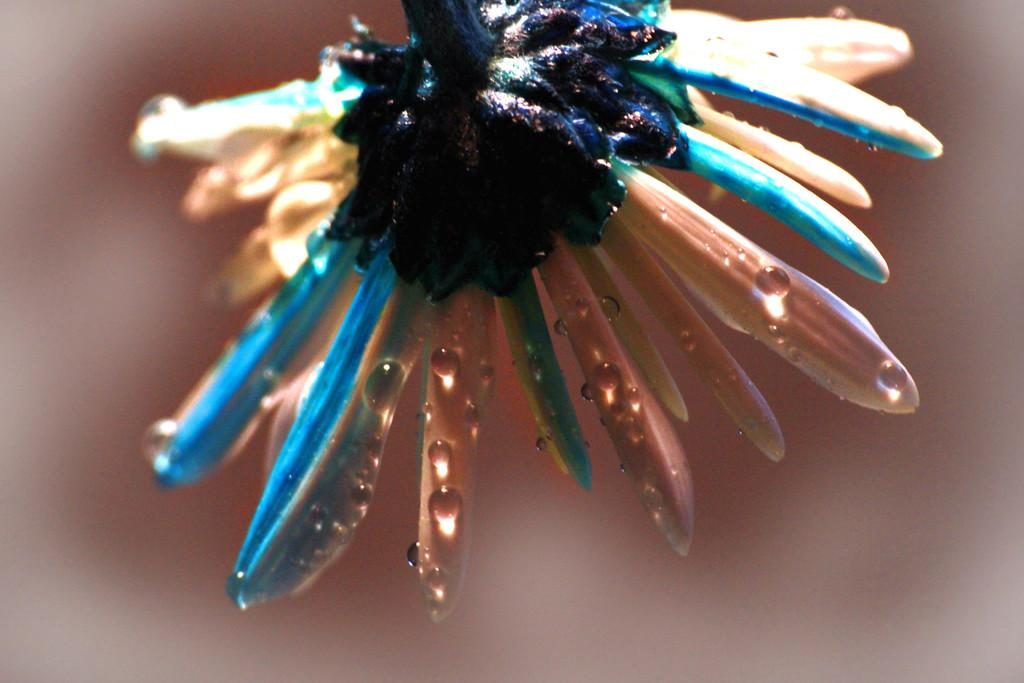What is the main subject of the picture? The main subject of the picture is a flower. Can you describe the flower in the image? The flower has water drops on it. What is the condition of the background in the image? The background of the image is blurry. What type of lock can be seen securing the pen in the image? There is no lock or pen present in the image; it features a flower with water drops and a blurry background. 